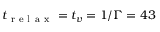<formula> <loc_0><loc_0><loc_500><loc_500>t _ { r e l a x } = t _ { v } = 1 / \Gamma = 4 3</formula> 